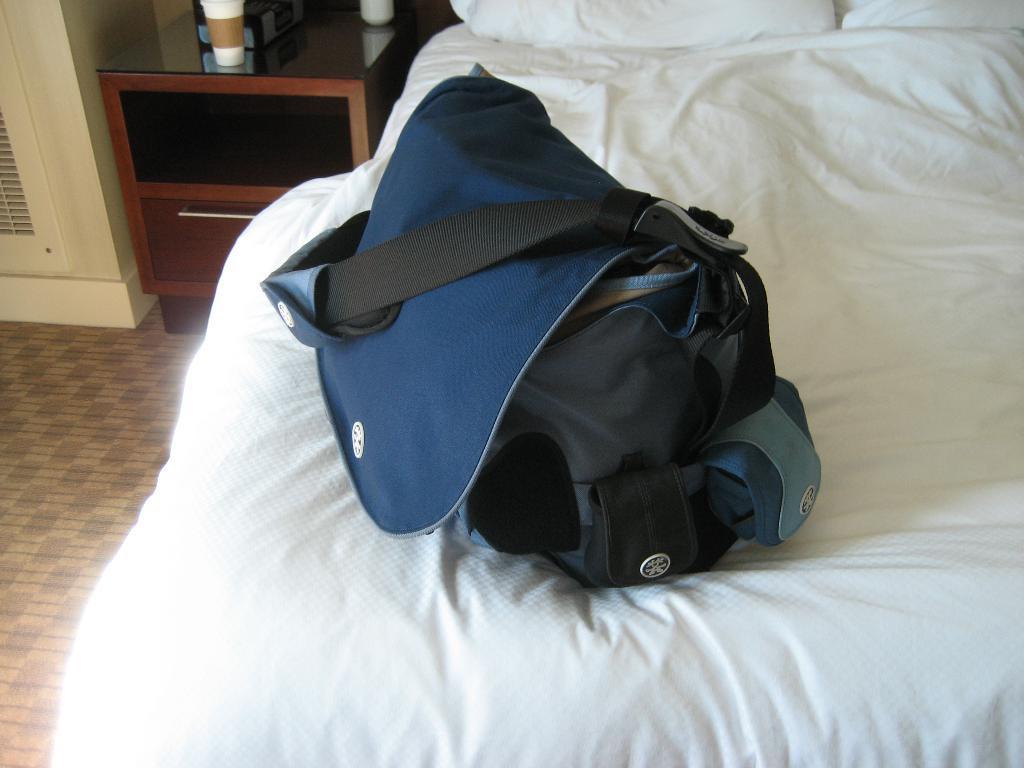Please provide a concise description of this image. In this image there is a bag on the bed, there are pillows truncated towards the top of the image, there are objects on the desk, there are objects truncated towards the top of the image, there is a wall truncated towards the left of the image. 